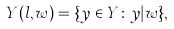<formula> <loc_0><loc_0><loc_500><loc_500>Y ( l , w ) = \{ y \in Y \colon y | w \} ,</formula> 